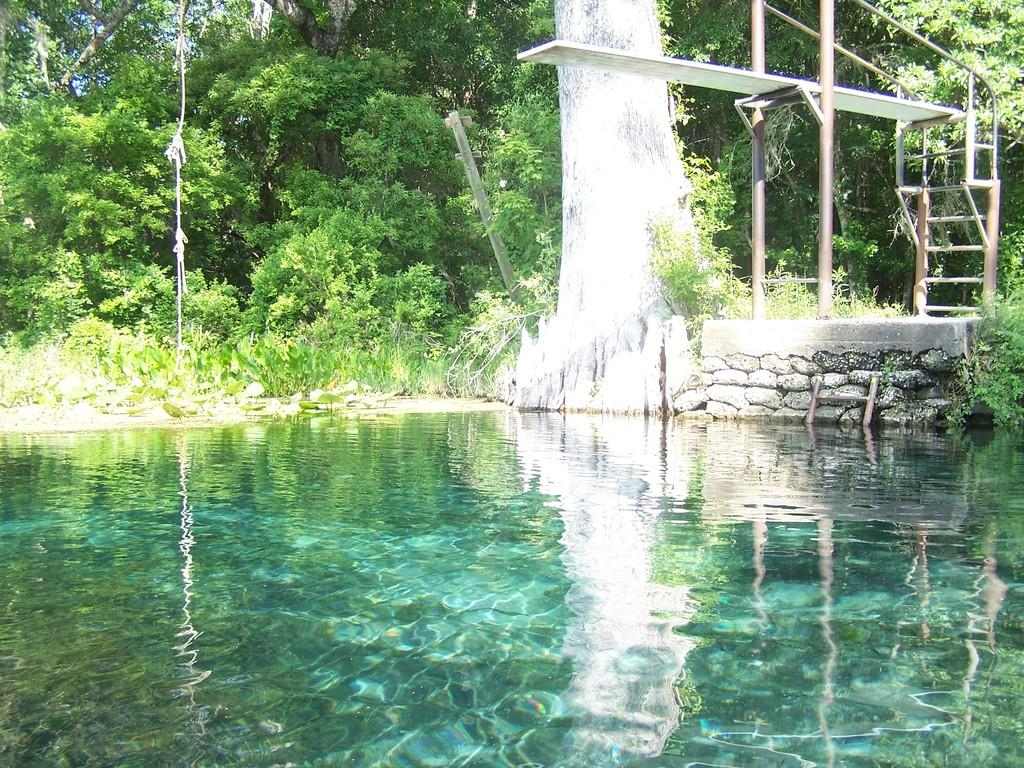What can be seen in the image that is related to water? There is water visible in the image. What type of structure is present in the image? There is a wall in the image. What type of vegetation is present in the image? There are trees and plants in the image. What objects can be seen that are related to construction or support? There are rods and rope in the image. How many sisters are visible in the image? There are no sisters present in the image. What type of crown can be seen on the trees in the image? There is no crown present on the trees in the image. 